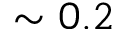<formula> <loc_0><loc_0><loc_500><loc_500>\sim 0 . 2</formula> 